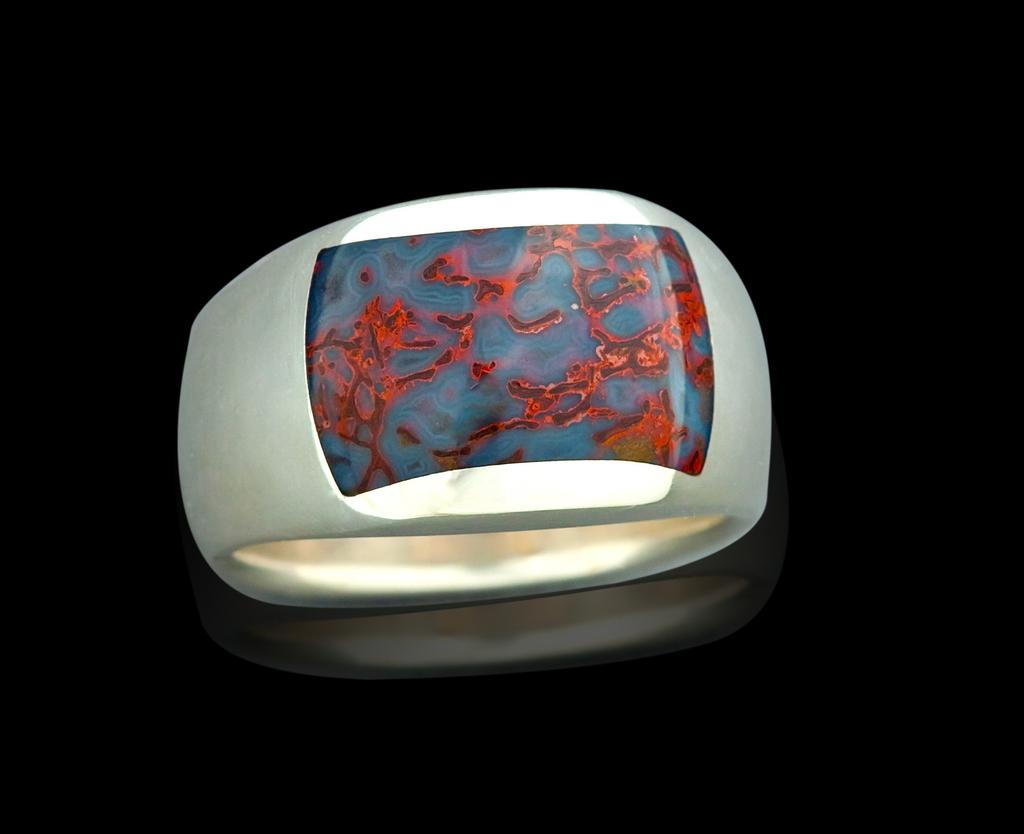What is the main subject of the image? The main subject of the image is an object that looks like a ring with a design. What can be observed about the background of the image? The background of the image is dark. What type of condition is the quilt in the image? There is no quilt present in the image, so it is not possible to determine its condition. How does the earthquake affect the ring-like object in the image? There is no earthquake depicted in the image, so it is not possible to determine its effect on the ring-like object. 